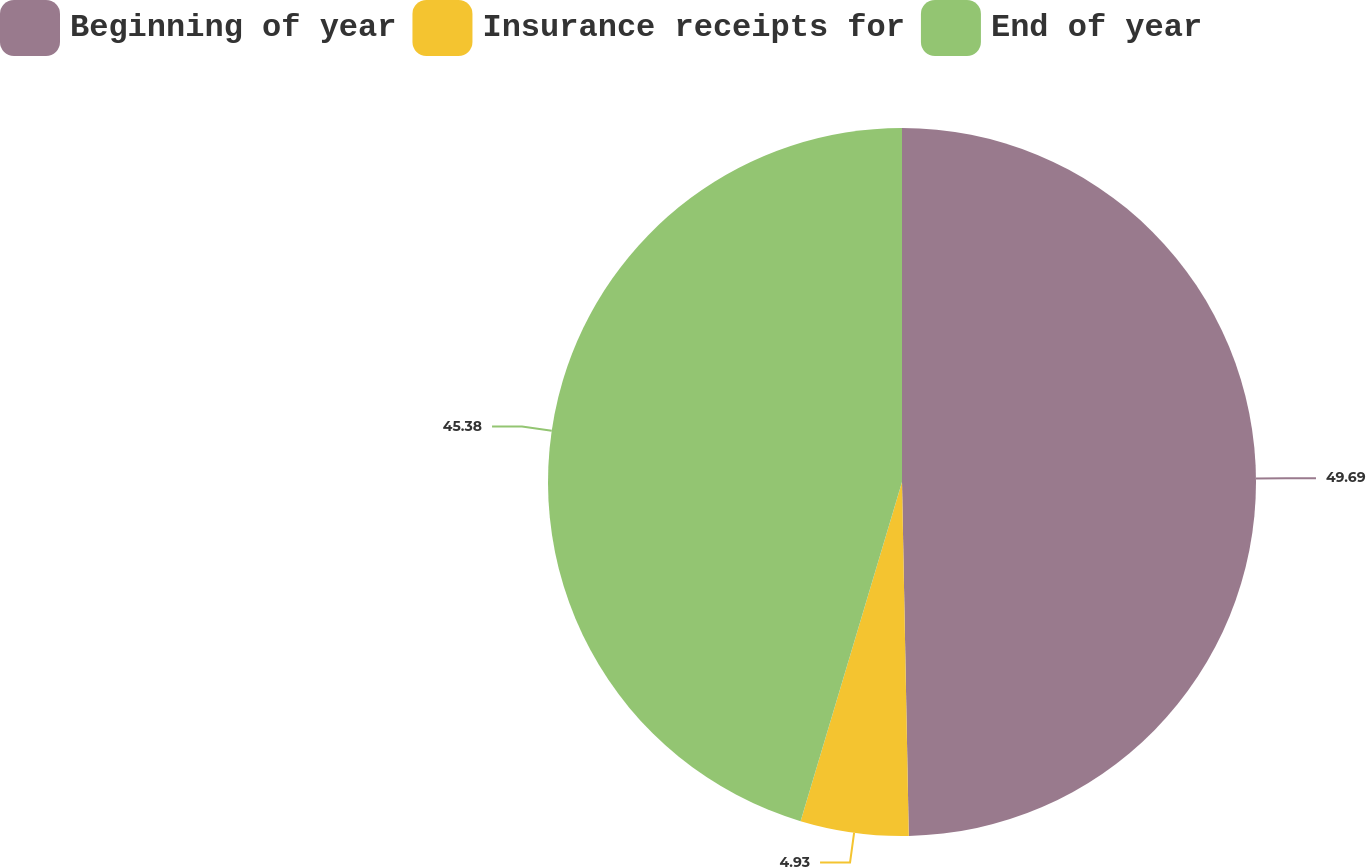Convert chart to OTSL. <chart><loc_0><loc_0><loc_500><loc_500><pie_chart><fcel>Beginning of year<fcel>Insurance receipts for<fcel>End of year<nl><fcel>49.7%<fcel>4.93%<fcel>45.38%<nl></chart> 